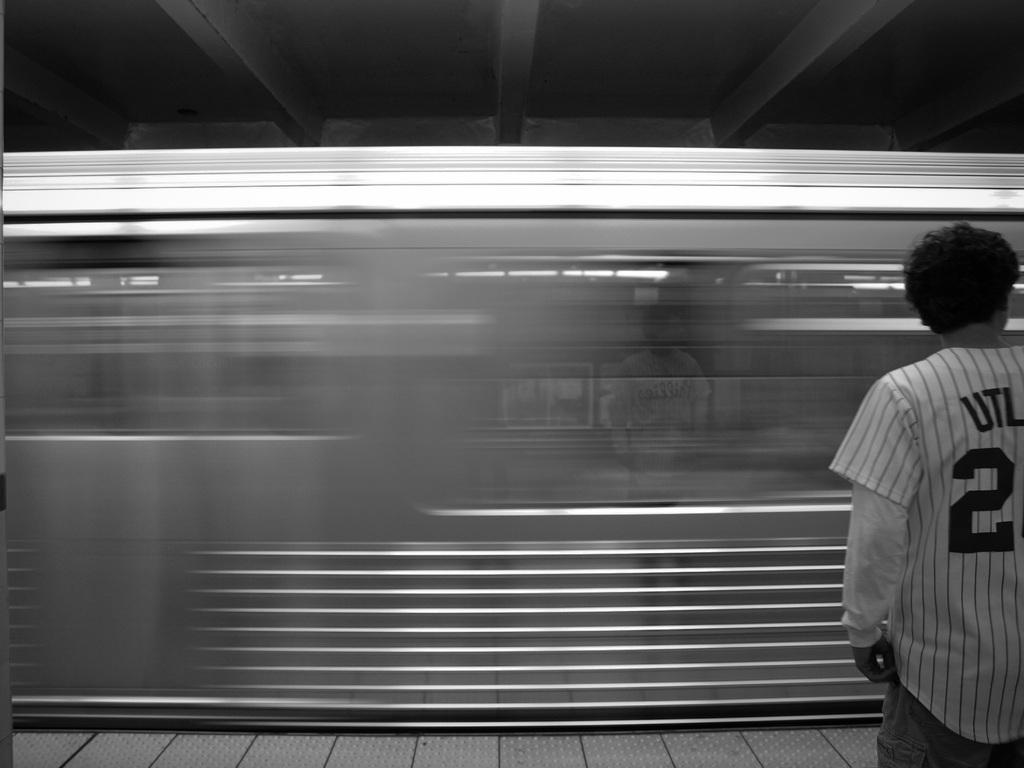What can be seen in the image? There is a person in the image. What is the person wearing? The person is wearing a white T-shirt. Where is the person standing? The person is standing on a platform. What is visible in the background of the image? There is a train in the background of the image. What is the train doing? The train is moving on the track. What type of fowl can be seen interacting with the person in the image? There is no fowl present in the image; it only features a person standing on a platform and a moving train in the background. What role does the actor play in the image? There is no actor or specific role mentioned in the image; it simply shows a person wearing a white T-shirt standing on a platform. 